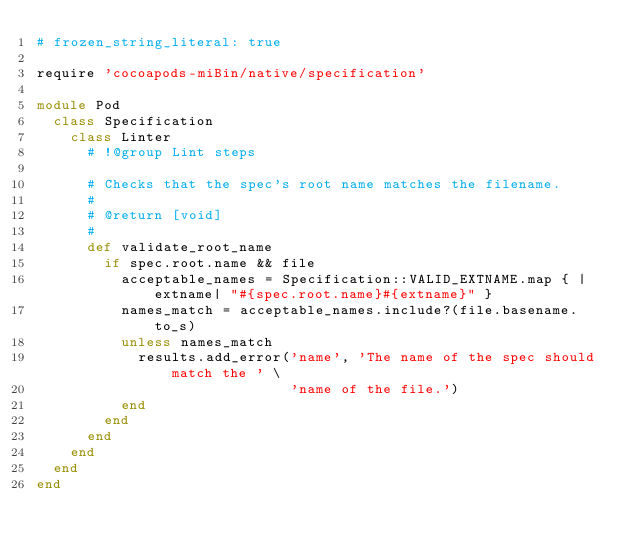Convert code to text. <code><loc_0><loc_0><loc_500><loc_500><_Ruby_># frozen_string_literal: true

require 'cocoapods-miBin/native/specification'

module Pod
  class Specification
    class Linter
      # !@group Lint steps

      # Checks that the spec's root name matches the filename.
      #
      # @return [void]
      #
      def validate_root_name
        if spec.root.name && file
          acceptable_names = Specification::VALID_EXTNAME.map { |extname| "#{spec.root.name}#{extname}" }
          names_match = acceptable_names.include?(file.basename.to_s)
          unless names_match
            results.add_error('name', 'The name of the spec should match the ' \
                              'name of the file.')
          end
        end
      end
    end
  end
end
</code> 